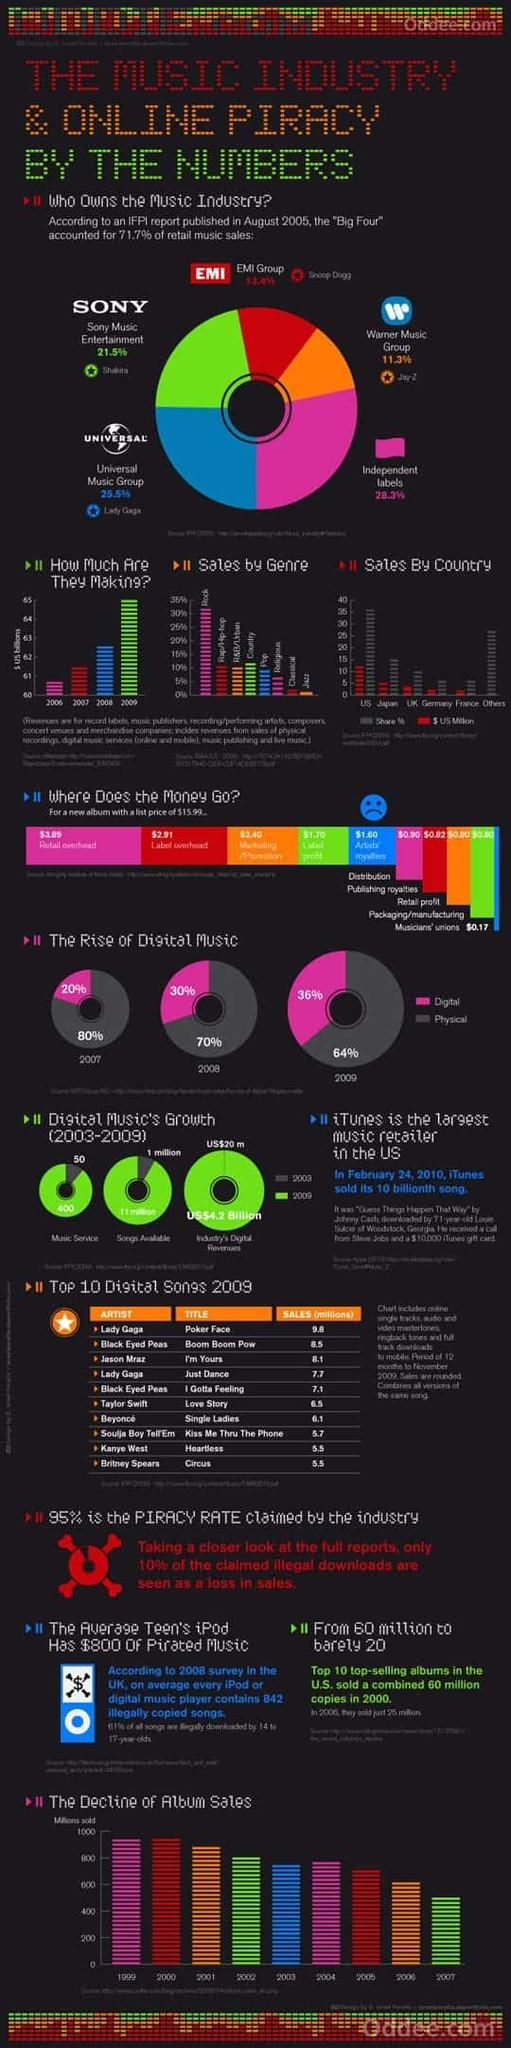Give some essential details in this illustration. The amount of money that goes towards publishing royalties from the $15.99 price of an album is $0.82. In 2008, approximately 30% of all music consumption occurred digitally. According to data, 28.3% of retail music sales are attributed to independent labels. Universal Music Group is the leading music industry sales company, also known as one of the "Big Four". In 2009, the fourth most popular song in terms of sales was "Just Dance. 